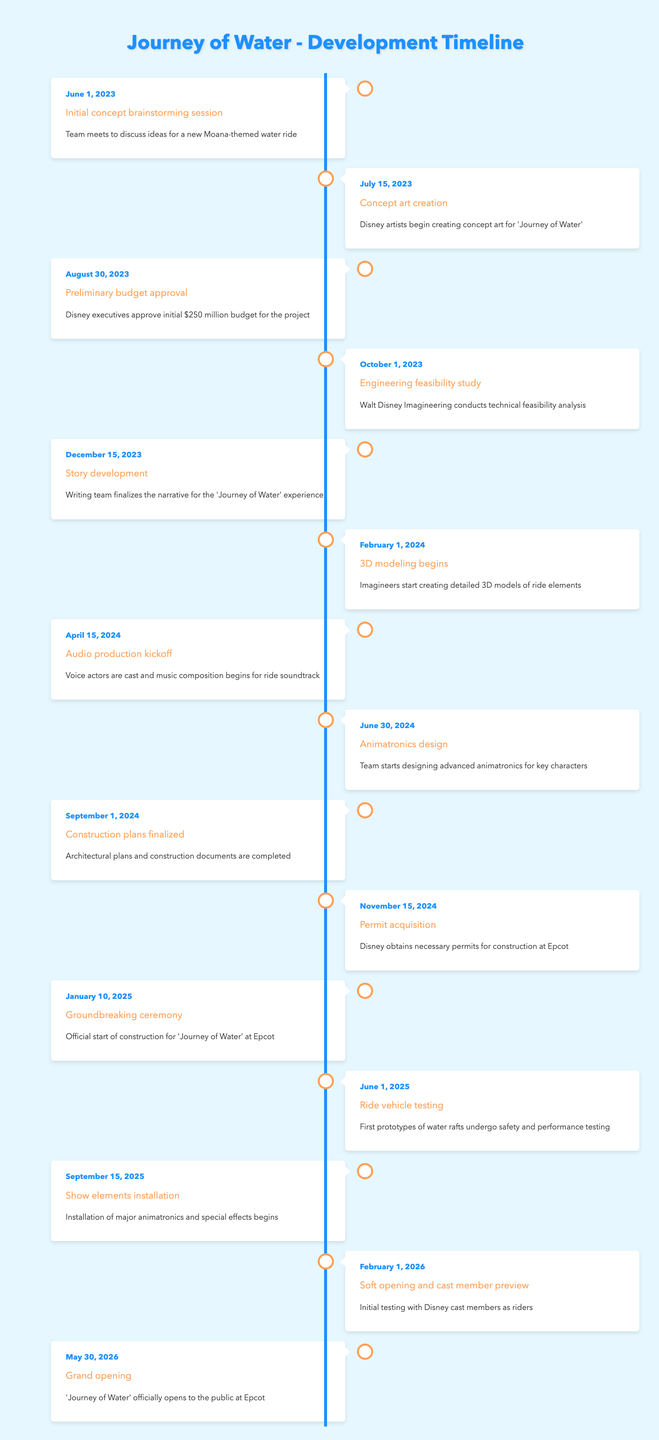What is the event that took place on June 1, 2023? The table shows the date and corresponding event descriptions. For June 1, 2023, the event listed is "Initial concept brainstorming session."
Answer: Initial concept brainstorming session Who was involved in the concept art creation on July 15, 2023? Referring to the entry for July 15, 2023, it states "Disney artists begin creating concept art for 'Journey of Water'," indicating that Disney artists were involved.
Answer: Disney artists What is the budget approved for the project? From the entry dated August 30, 2023, the preliminary budget approved is $250 million.
Answer: $250 million Is there an event listed for October 1, 2023? Yes, the table includes an event for October 1, 2023, which is "Engineering feasibility study."
Answer: Yes How much time elapsed between the groundbreaking ceremony and the grand opening? The groundbreaking ceremony is on January 10, 2025, and the grand opening is on May 30, 2026. Calculating the interval: from January 10, 2025, to January 10, 2026, is 1 year, and from January 10, 2026, to May 30, 2026, is 4 months and 20 days. In total, that's 1 year and 4 months and 20 days.
Answer: 1 year and 4 months and 20 days What was the last event listed before the grand opening? The last event before the grand opening on May 30, 2026, is "Soft opening and cast member preview" on February 1, 2026.
Answer: Soft opening and cast member preview Were there any animatronics designed before the construction plans were finalized? The data shows that animatronics design began on June 30, 2024, which is after the construction plans were finalized on September 1, 2024. Therefore, the answer is no.
Answer: No How many months were there between the initial concept brainstorming session and the audio production kickoff? The initial concept brainstorming session was on June 1, 2023, and the audio production kickoff occurred on April 15, 2024. From June 2023 to April 2024 is 10 months and 14 days. Thus, it is approximately 10 months from one event to the other.
Answer: 10 months What is the total number of events listed on the timeline? By counting all the unique events from the timeline provided, there are 15 events listed.
Answer: 15 